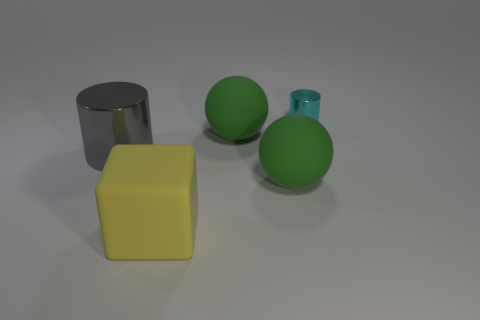Add 1 yellow rubber objects. How many objects exist? 6 Subtract all cylinders. How many objects are left? 3 Subtract all tiny green metallic blocks. Subtract all small cyan metal things. How many objects are left? 4 Add 2 green things. How many green things are left? 4 Add 5 cyan things. How many cyan things exist? 6 Subtract 0 gray balls. How many objects are left? 5 Subtract all yellow spheres. Subtract all red cylinders. How many spheres are left? 2 